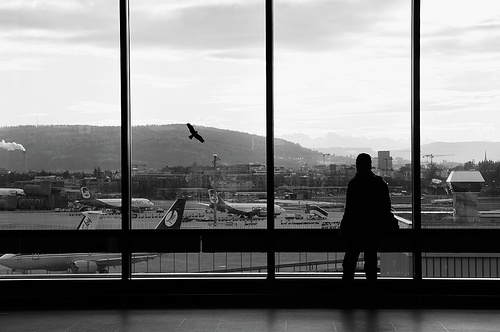Describe the objects in this image and their specific colors. I can see people in white, black, gray, darkgray, and lightgray tones, airplane in white, gray, black, darkgray, and lightgray tones, airplane in white, black, gray, darkgray, and lightgray tones, airplane in white, black, gray, darkgray, and lightgray tones, and airplane in white, gray, black, darkgray, and lightgray tones in this image. 